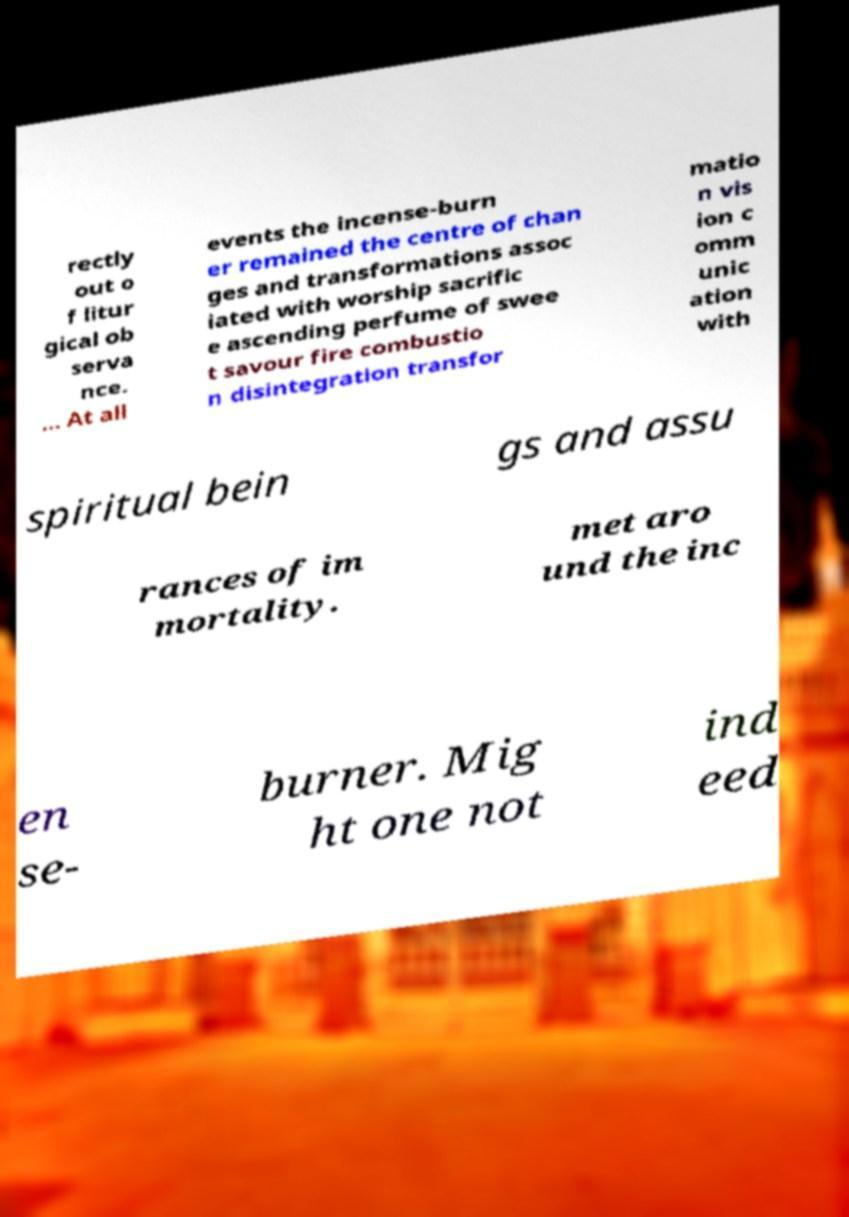Can you accurately transcribe the text from the provided image for me? rectly out o f litur gical ob serva nce. … At all events the incense-burn er remained the centre of chan ges and transformations assoc iated with worship sacrific e ascending perfume of swee t savour fire combustio n disintegration transfor matio n vis ion c omm unic ation with spiritual bein gs and assu rances of im mortality. met aro und the inc en se- burner. Mig ht one not ind eed 